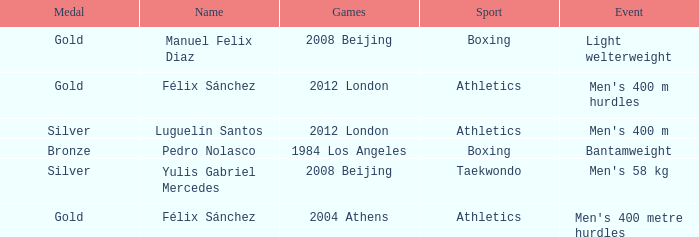Help me parse the entirety of this table. {'header': ['Medal', 'Name', 'Games', 'Sport', 'Event'], 'rows': [['Gold', 'Manuel Felix Diaz', '2008 Beijing', 'Boxing', 'Light welterweight'], ['Gold', 'Félix Sánchez', '2012 London', 'Athletics', "Men's 400 m hurdles"], ['Silver', 'Luguelín Santos', '2012 London', 'Athletics', "Men's 400 m"], ['Bronze', 'Pedro Nolasco', '1984 Los Angeles', 'Boxing', 'Bantamweight'], ['Silver', 'Yulis Gabriel Mercedes', '2008 Beijing', 'Taekwondo', "Men's 58 kg"], ['Gold', 'Félix Sánchez', '2004 Athens', 'Athletics', "Men's 400 metre hurdles"]]} Which Sport had an Event of men's 400 m hurdles? Athletics. 